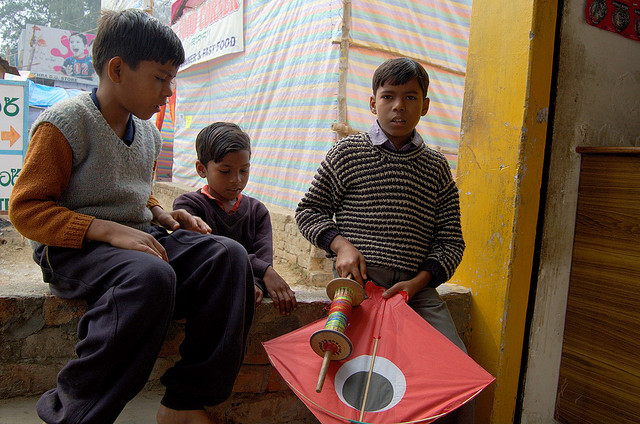Please transcribe the text in this image. FOOD COR OK 6 